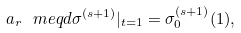<formula> <loc_0><loc_0><loc_500><loc_500>a _ { r } \ m e q d \sigma ^ { ( s + 1 ) } | _ { t = 1 } = \sigma _ { 0 } ^ { ( s + 1 ) } ( 1 ) ,</formula> 